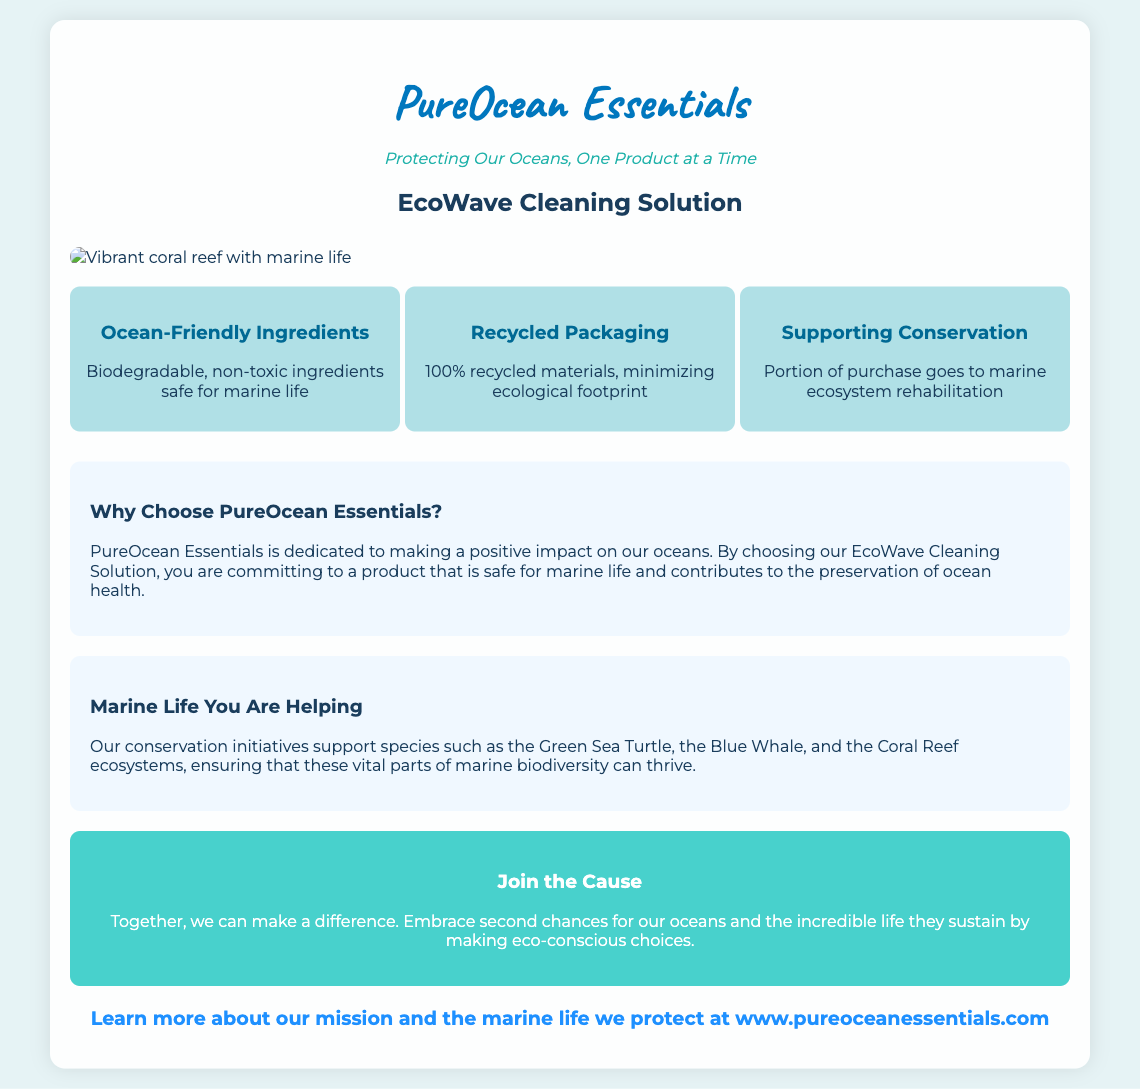What is the product name? The product name is clearly mentioned at the top of the document.
Answer: EcoWave Cleaning Solution What type of ingredients does the product use? The packaging outlines the type of ingredients used in the product.
Answer: Ocean-Friendly Ingredients What percent of materials used in packaging are recycled? The document specifically mentions the recycling rate of the packaging materials.
Answer: 100% recycled materials Which marine species are mentioned in the document? The document lists specific marine species that the conservation initiatives support.
Answer: Green Sea Turtle, Blue Whale, Coral Reef What is the main mission of PureOcean Essentials? The document describes the overarching goal of the brand regarding ocean preservation efforts.
Answer: Protecting Our Oceans What message is emphasized in the awareness section? The awareness message encourages engagement with the cause presented in the packaging.
Answer: Embrace second chances for our oceans What does a portion of the purchase go towards? The packaging states where part of the proceeds will be allocated.
Answer: Marine ecosystem rehabilitation What style of font is used for the title? The document describes the font style used for the title of the product.
Answer: Caveat What is the background color of the container? The background color of the container is specified in the document.
Answer: rgba(255, 255, 255, 0.9) 